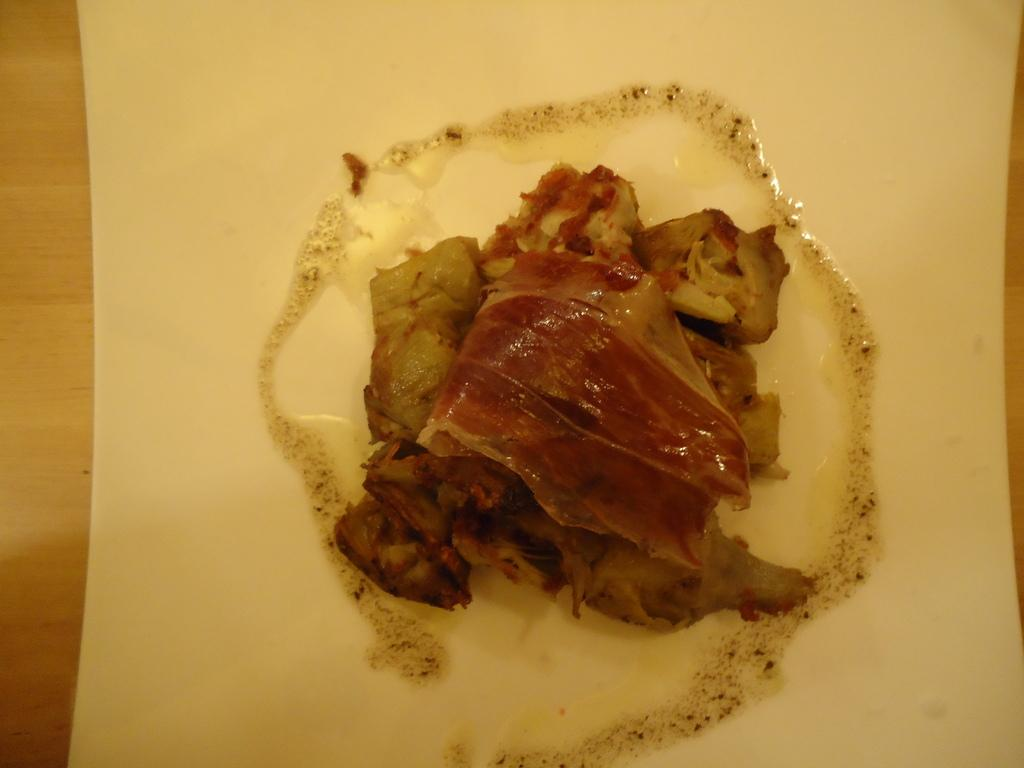What piece of furniture is present in the image? There is a table in the image. What is placed on the table in the image? There is a food item placed on a plate on the table. What type of bushes can be seen growing around the table in the image? There are no bushes visible in the image; it only shows a table with a food item on a plate. 